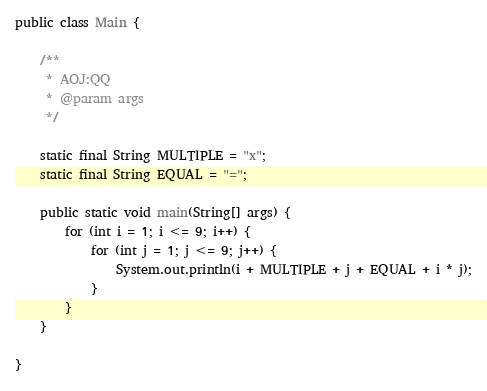Convert code to text. <code><loc_0><loc_0><loc_500><loc_500><_Java_>public class Main {

	/**
	 * AOJ:QQ
	 * @param args
	 */

	static final String MULTIPLE = "x";
	static final String EQUAL = "=";

	public static void main(String[] args) {
		for (int i = 1; i <= 9; i++) {
			for (int j = 1; j <= 9; j++) {
				System.out.println(i + MULTIPLE + j + EQUAL + i * j);
			}
		}
	}

}</code> 